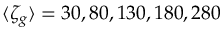<formula> <loc_0><loc_0><loc_500><loc_500>\langle \zeta _ { g } \rangle = 3 0 , 8 0 , 1 3 0 , 1 8 0 , 2 8 0</formula> 